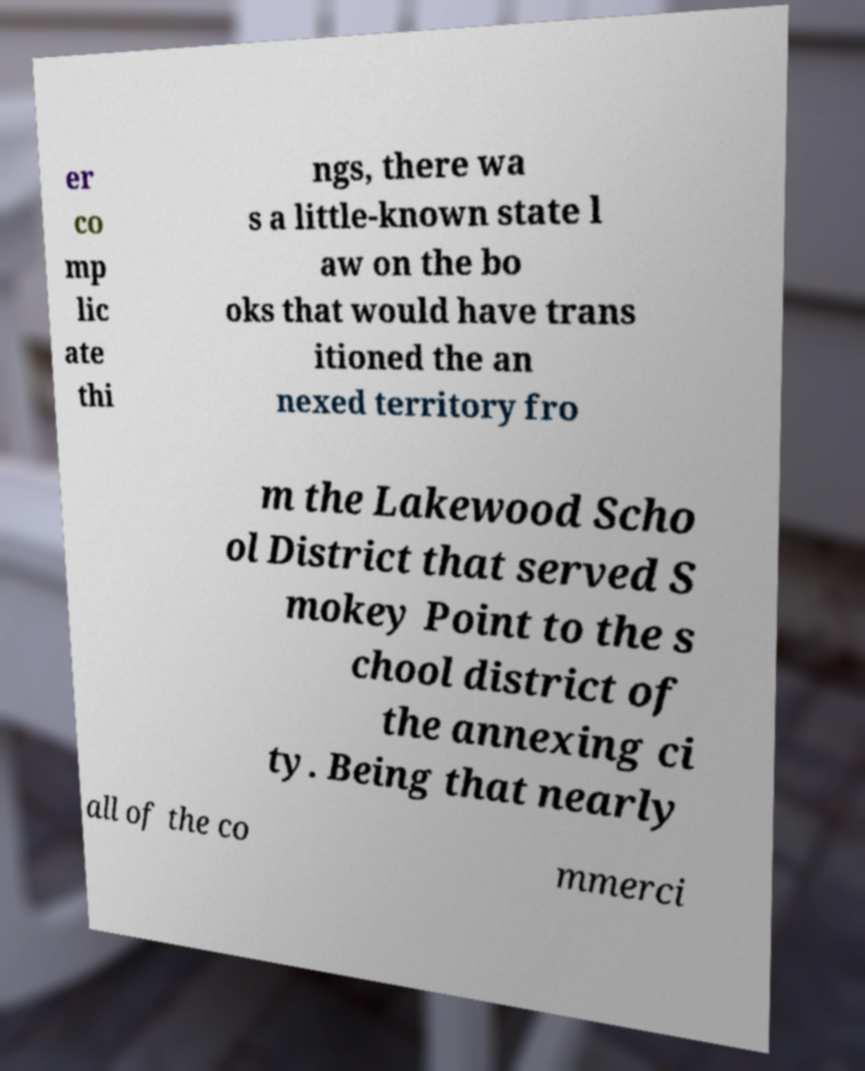Can you read and provide the text displayed in the image?This photo seems to have some interesting text. Can you extract and type it out for me? er co mp lic ate thi ngs, there wa s a little-known state l aw on the bo oks that would have trans itioned the an nexed territory fro m the Lakewood Scho ol District that served S mokey Point to the s chool district of the annexing ci ty. Being that nearly all of the co mmerci 